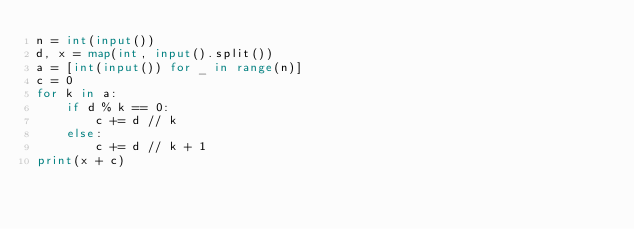<code> <loc_0><loc_0><loc_500><loc_500><_Python_>n = int(input())
d, x = map(int, input().split())
a = [int(input()) for _ in range(n)]
c = 0
for k in a:
    if d % k == 0:
        c += d // k
    else:
        c += d // k + 1
print(x + c)</code> 